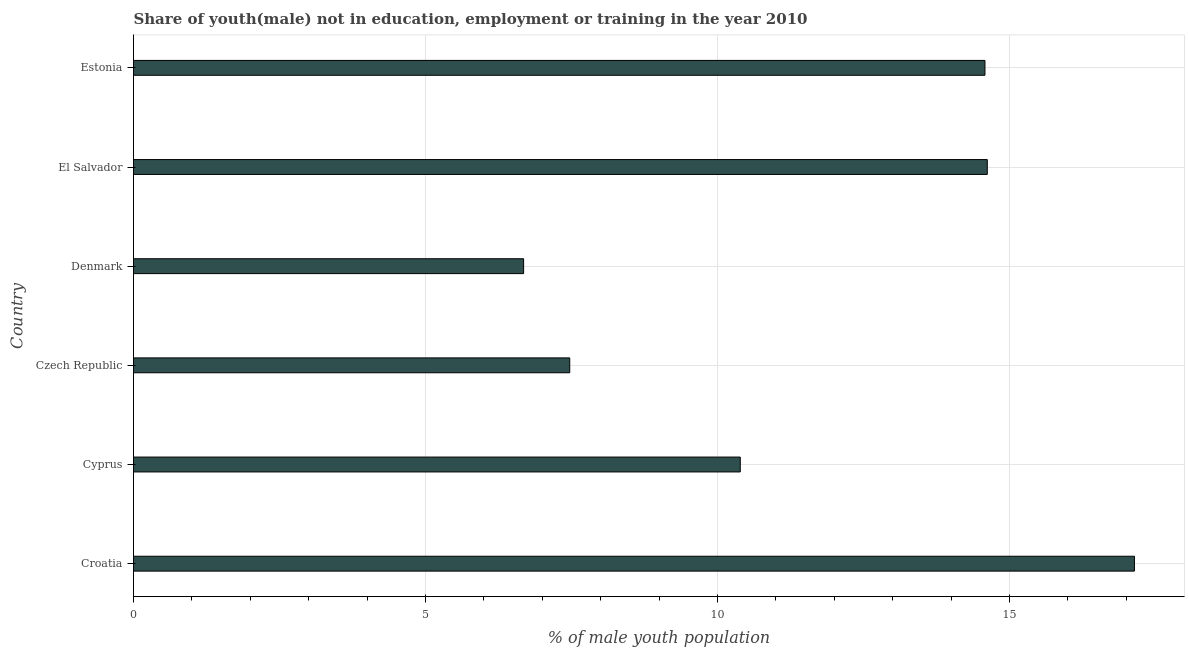What is the title of the graph?
Give a very brief answer. Share of youth(male) not in education, employment or training in the year 2010. What is the label or title of the X-axis?
Your answer should be compact. % of male youth population. What is the label or title of the Y-axis?
Keep it short and to the point. Country. What is the unemployed male youth population in Denmark?
Give a very brief answer. 6.68. Across all countries, what is the maximum unemployed male youth population?
Your answer should be compact. 17.14. Across all countries, what is the minimum unemployed male youth population?
Offer a terse response. 6.68. In which country was the unemployed male youth population maximum?
Ensure brevity in your answer.  Croatia. In which country was the unemployed male youth population minimum?
Your response must be concise. Denmark. What is the sum of the unemployed male youth population?
Provide a succinct answer. 70.88. What is the difference between the unemployed male youth population in Denmark and El Salvador?
Your response must be concise. -7.94. What is the average unemployed male youth population per country?
Keep it short and to the point. 11.81. What is the median unemployed male youth population?
Your response must be concise. 12.49. What is the ratio of the unemployed male youth population in Cyprus to that in Czech Republic?
Offer a terse response. 1.39. Is the unemployed male youth population in Cyprus less than that in Czech Republic?
Make the answer very short. No. What is the difference between the highest and the second highest unemployed male youth population?
Provide a short and direct response. 2.52. What is the difference between the highest and the lowest unemployed male youth population?
Keep it short and to the point. 10.46. What is the difference between two consecutive major ticks on the X-axis?
Offer a terse response. 5. Are the values on the major ticks of X-axis written in scientific E-notation?
Provide a succinct answer. No. What is the % of male youth population in Croatia?
Keep it short and to the point. 17.14. What is the % of male youth population of Cyprus?
Give a very brief answer. 10.39. What is the % of male youth population of Czech Republic?
Give a very brief answer. 7.47. What is the % of male youth population of Denmark?
Provide a succinct answer. 6.68. What is the % of male youth population of El Salvador?
Give a very brief answer. 14.62. What is the % of male youth population of Estonia?
Give a very brief answer. 14.58. What is the difference between the % of male youth population in Croatia and Cyprus?
Your response must be concise. 6.75. What is the difference between the % of male youth population in Croatia and Czech Republic?
Provide a short and direct response. 9.67. What is the difference between the % of male youth population in Croatia and Denmark?
Keep it short and to the point. 10.46. What is the difference between the % of male youth population in Croatia and El Salvador?
Make the answer very short. 2.52. What is the difference between the % of male youth population in Croatia and Estonia?
Keep it short and to the point. 2.56. What is the difference between the % of male youth population in Cyprus and Czech Republic?
Keep it short and to the point. 2.92. What is the difference between the % of male youth population in Cyprus and Denmark?
Offer a terse response. 3.71. What is the difference between the % of male youth population in Cyprus and El Salvador?
Offer a very short reply. -4.23. What is the difference between the % of male youth population in Cyprus and Estonia?
Provide a succinct answer. -4.19. What is the difference between the % of male youth population in Czech Republic and Denmark?
Offer a terse response. 0.79. What is the difference between the % of male youth population in Czech Republic and El Salvador?
Ensure brevity in your answer.  -7.15. What is the difference between the % of male youth population in Czech Republic and Estonia?
Your response must be concise. -7.11. What is the difference between the % of male youth population in Denmark and El Salvador?
Offer a very short reply. -7.94. What is the ratio of the % of male youth population in Croatia to that in Cyprus?
Ensure brevity in your answer.  1.65. What is the ratio of the % of male youth population in Croatia to that in Czech Republic?
Ensure brevity in your answer.  2.29. What is the ratio of the % of male youth population in Croatia to that in Denmark?
Your answer should be very brief. 2.57. What is the ratio of the % of male youth population in Croatia to that in El Salvador?
Give a very brief answer. 1.17. What is the ratio of the % of male youth population in Croatia to that in Estonia?
Provide a short and direct response. 1.18. What is the ratio of the % of male youth population in Cyprus to that in Czech Republic?
Offer a terse response. 1.39. What is the ratio of the % of male youth population in Cyprus to that in Denmark?
Make the answer very short. 1.55. What is the ratio of the % of male youth population in Cyprus to that in El Salvador?
Provide a short and direct response. 0.71. What is the ratio of the % of male youth population in Cyprus to that in Estonia?
Offer a very short reply. 0.71. What is the ratio of the % of male youth population in Czech Republic to that in Denmark?
Your answer should be very brief. 1.12. What is the ratio of the % of male youth population in Czech Republic to that in El Salvador?
Your answer should be very brief. 0.51. What is the ratio of the % of male youth population in Czech Republic to that in Estonia?
Offer a very short reply. 0.51. What is the ratio of the % of male youth population in Denmark to that in El Salvador?
Make the answer very short. 0.46. What is the ratio of the % of male youth population in Denmark to that in Estonia?
Provide a short and direct response. 0.46. 